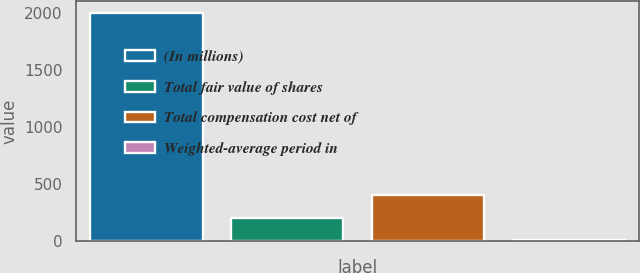Convert chart to OTSL. <chart><loc_0><loc_0><loc_500><loc_500><bar_chart><fcel>(In millions)<fcel>Total fair value of shares<fcel>Total compensation cost net of<fcel>Weighted-average period in<nl><fcel>2007<fcel>202.5<fcel>403<fcel>2<nl></chart> 